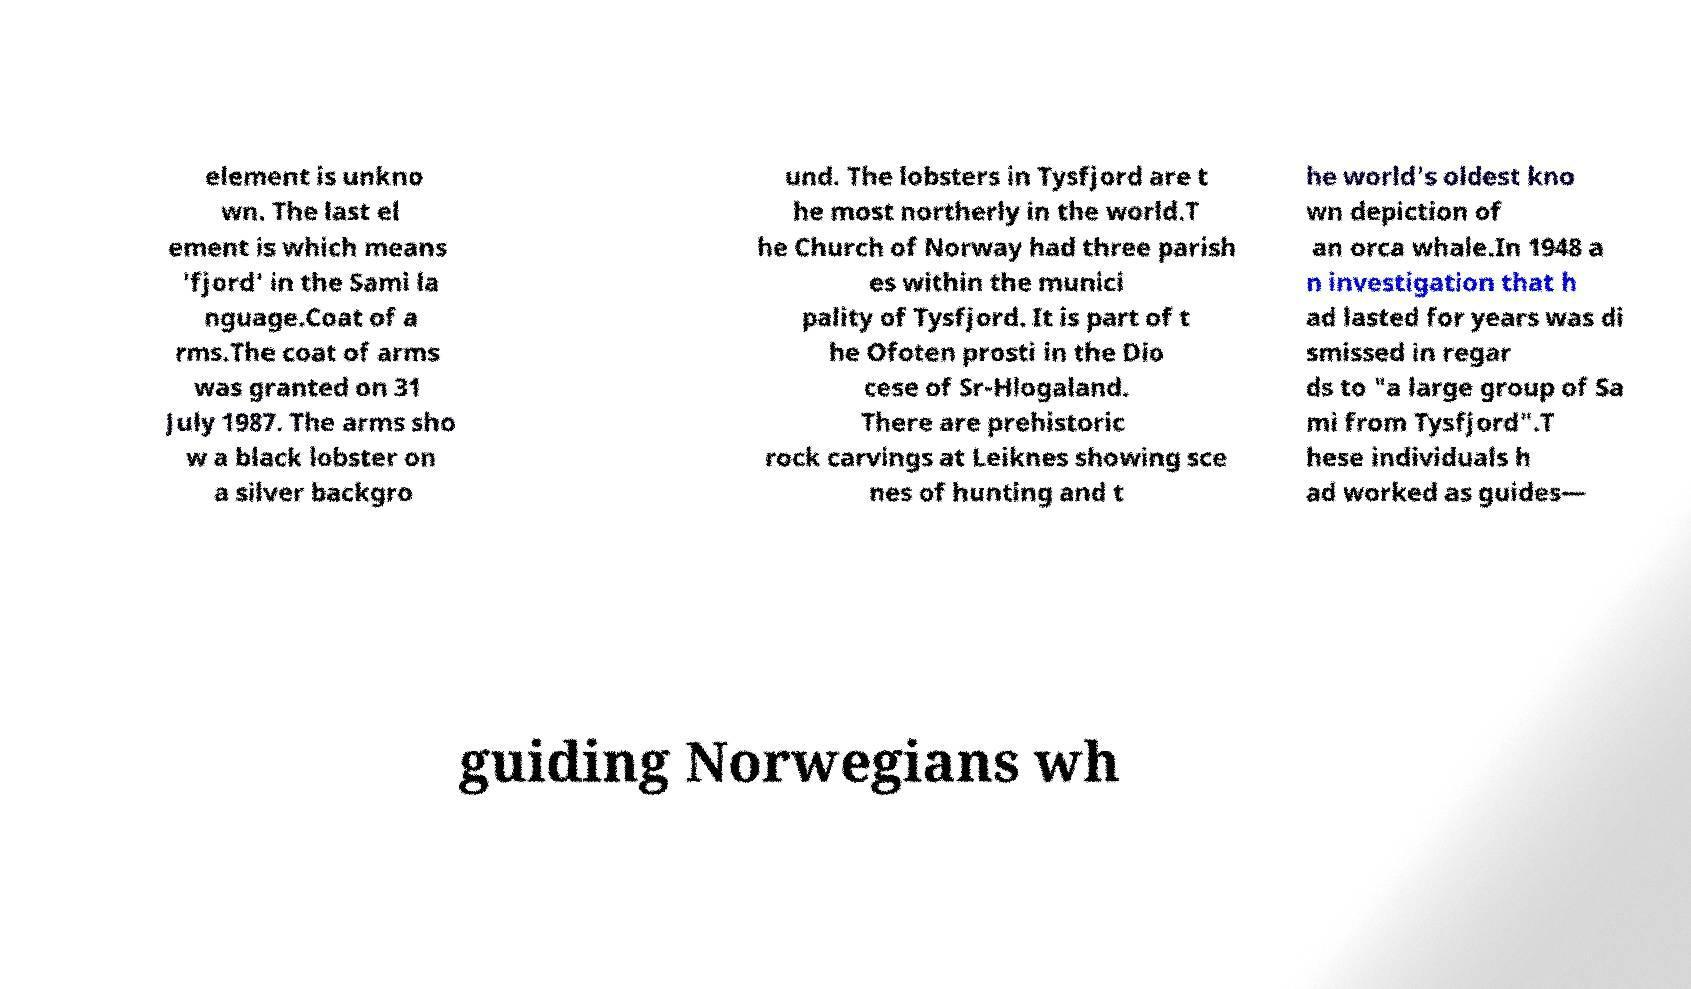Please identify and transcribe the text found in this image. element is unkno wn. The last el ement is which means 'fjord' in the Sami la nguage.Coat of a rms.The coat of arms was granted on 31 July 1987. The arms sho w a black lobster on a silver backgro und. The lobsters in Tysfjord are t he most northerly in the world.T he Church of Norway had three parish es within the munici pality of Tysfjord. It is part of t he Ofoten prosti in the Dio cese of Sr-Hlogaland. There are prehistoric rock carvings at Leiknes showing sce nes of hunting and t he world's oldest kno wn depiction of an orca whale.In 1948 a n investigation that h ad lasted for years was di smissed in regar ds to "a large group of Sa mi from Tysfjord".T hese individuals h ad worked as guides— guiding Norwegians wh 